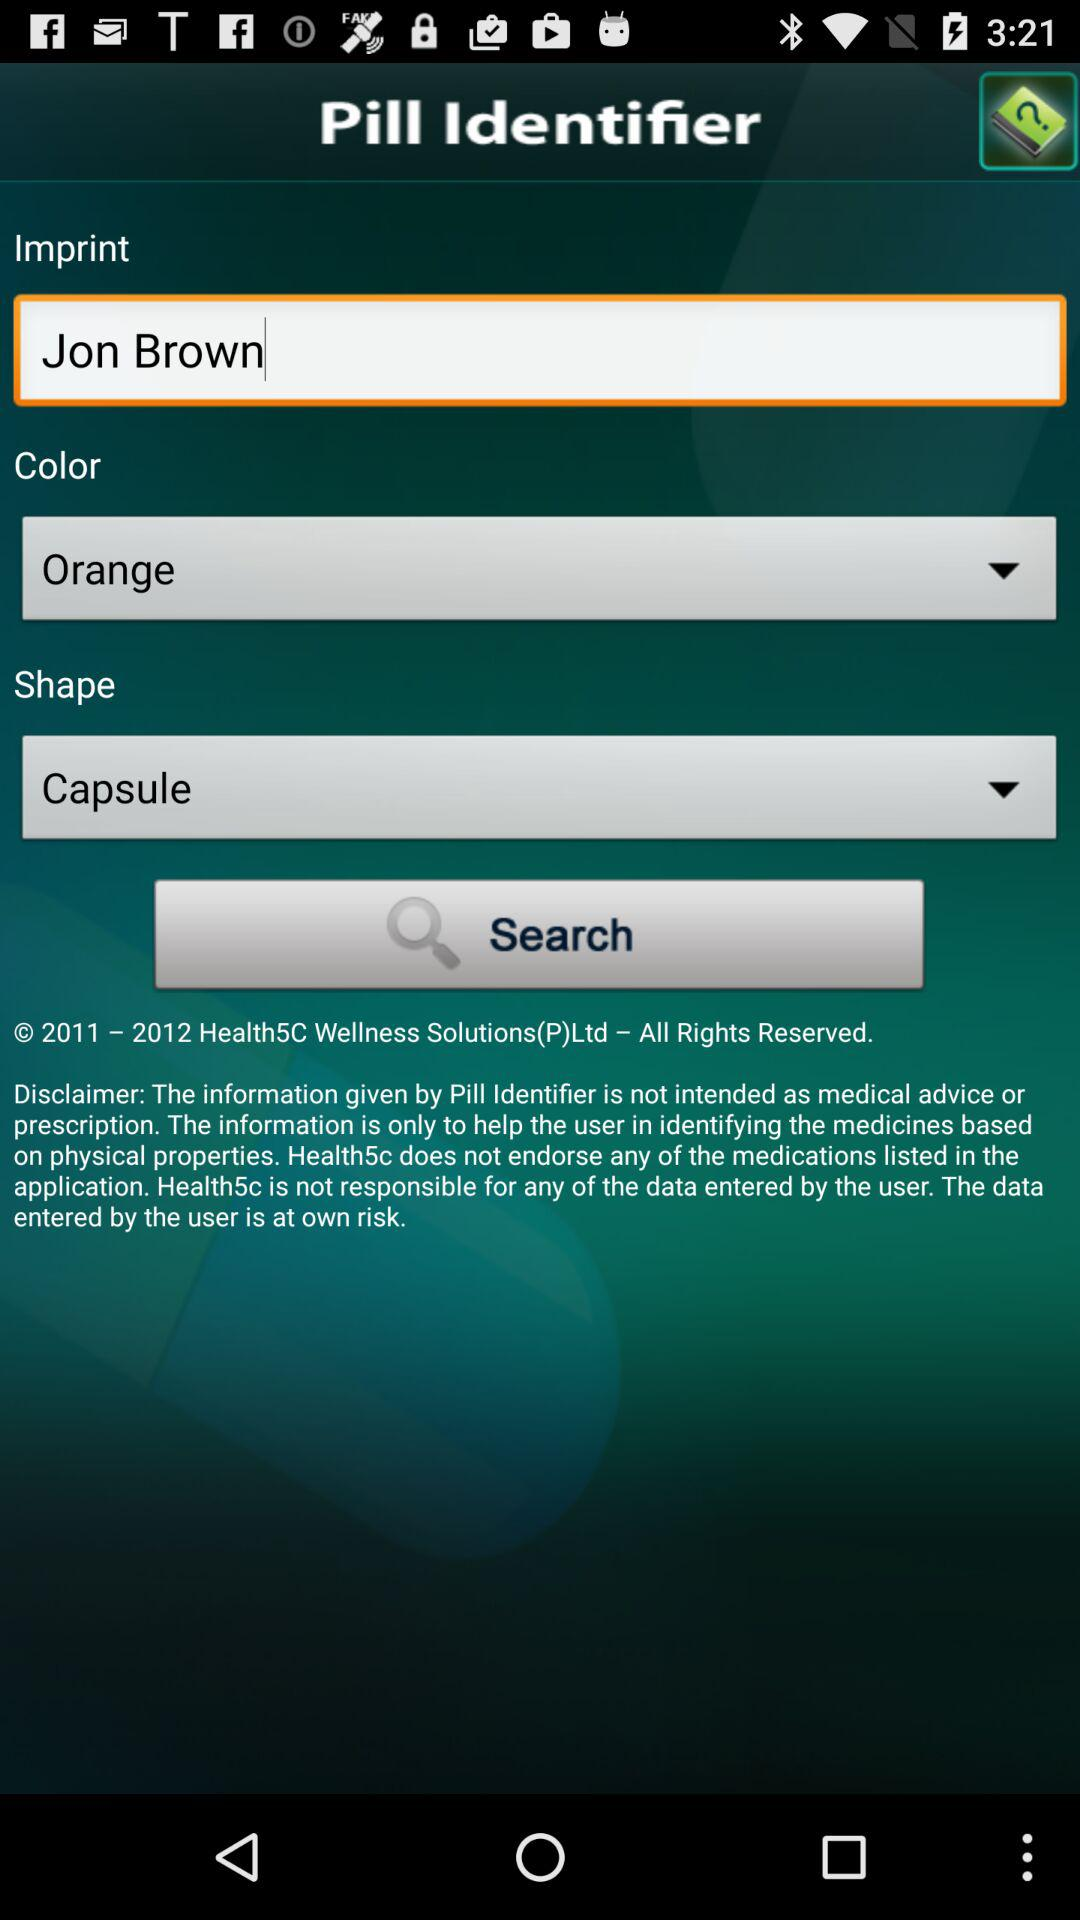How many text inputs have a value of Jon Brown?
Answer the question using a single word or phrase. 1 